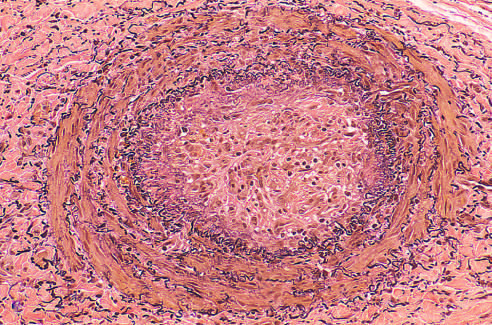what is stained for elastic tissue?
Answer the question using a single word or phrase. A thrombosed artery 